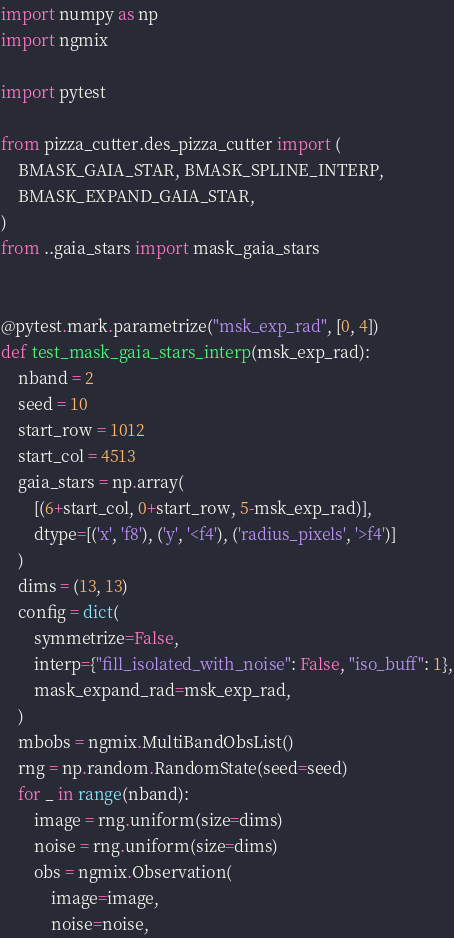Convert code to text. <code><loc_0><loc_0><loc_500><loc_500><_Python_>import numpy as np
import ngmix

import pytest

from pizza_cutter.des_pizza_cutter import (
    BMASK_GAIA_STAR, BMASK_SPLINE_INTERP,
    BMASK_EXPAND_GAIA_STAR,
)
from ..gaia_stars import mask_gaia_stars


@pytest.mark.parametrize("msk_exp_rad", [0, 4])
def test_mask_gaia_stars_interp(msk_exp_rad):
    nband = 2
    seed = 10
    start_row = 1012
    start_col = 4513
    gaia_stars = np.array(
        [(6+start_col, 0+start_row, 5-msk_exp_rad)],
        dtype=[('x', 'f8'), ('y', '<f4'), ('radius_pixels', '>f4')]
    )
    dims = (13, 13)
    config = dict(
        symmetrize=False,
        interp={"fill_isolated_with_noise": False, "iso_buff": 1},
        mask_expand_rad=msk_exp_rad,
    )
    mbobs = ngmix.MultiBandObsList()
    rng = np.random.RandomState(seed=seed)
    for _ in range(nband):
        image = rng.uniform(size=dims)
        noise = rng.uniform(size=dims)
        obs = ngmix.Observation(
            image=image,
            noise=noise,</code> 